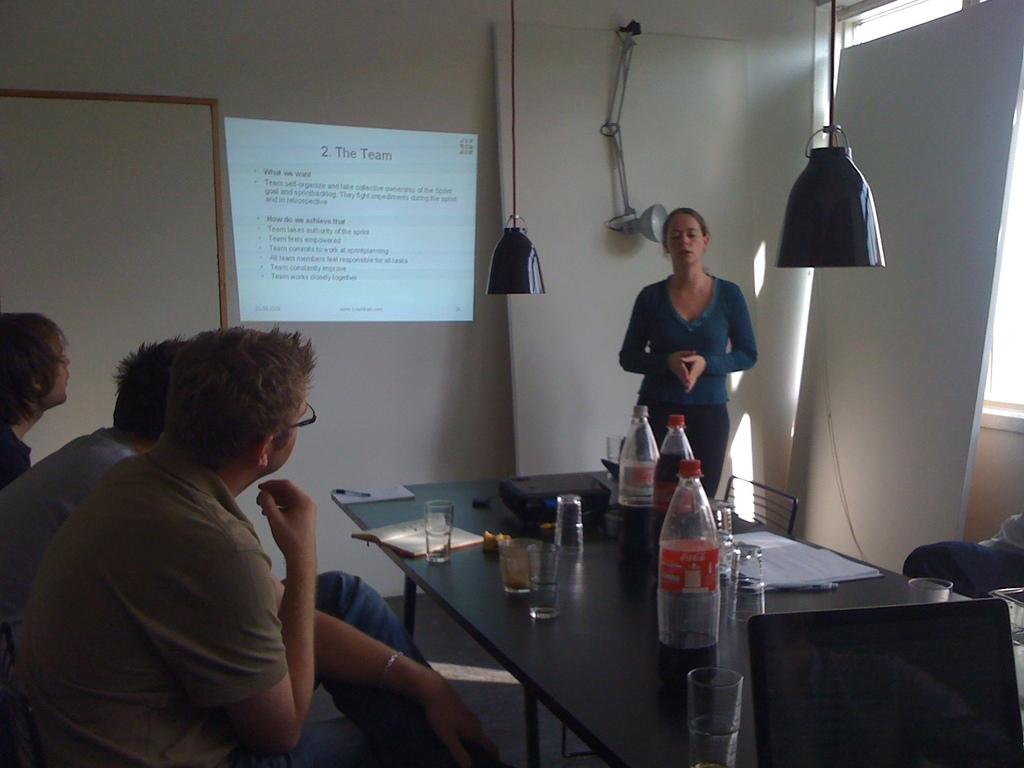What is the primary subject in the image? There is a woman standing in the image. What is located near the woman? There is a table near the woman. What objects can be seen on the table? There is a bottle, a glass, a book, and a pen on the table. What type of furniture is present near the table? There is a chair near the table. What can be seen in the background of the image? There is a group of persons sitting, a screen, a lamp, and a wall in the background. What type of rake is being used by the woman in the image? There is no mention of a rake in the image or the provided facts, so it cannot be determined if a rake is present or being used. 